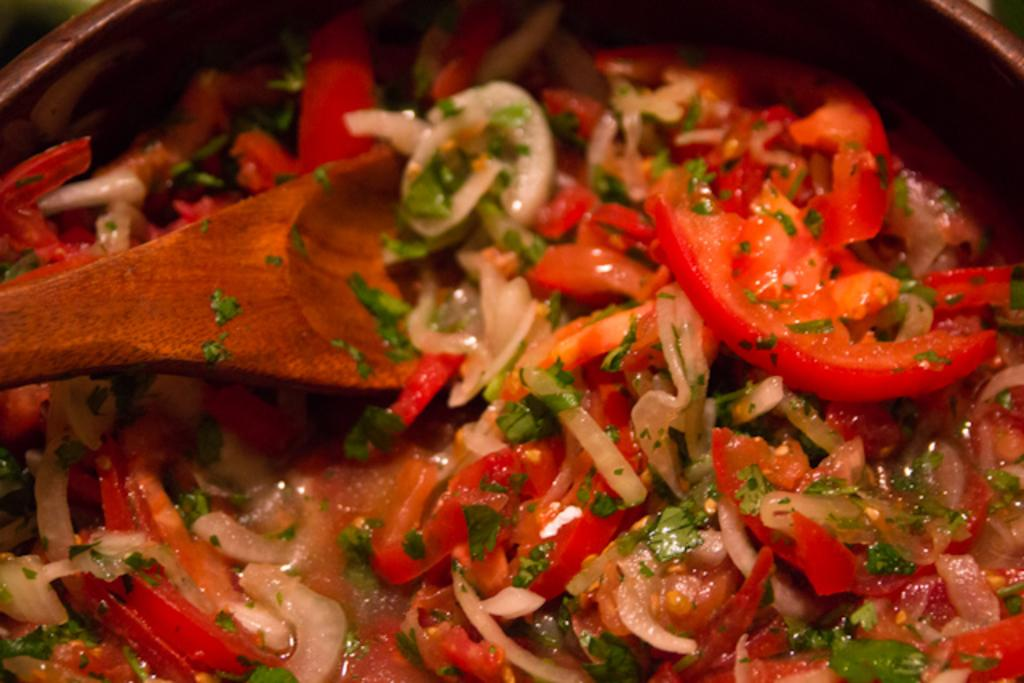What type of food can be seen in the image? The food in the image has white, red, and green colors. How is the food presented in the image? The food is in a bowl. What utensil is visible in the image? There is a wooden spoon in the image. How much sugar is in the food in the image? The provided facts do not mention the presence of sugar in the food, so it cannot be determined from the image. 